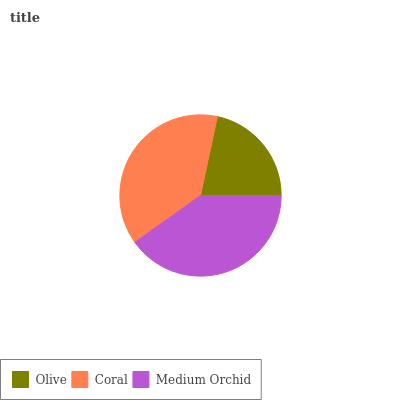Is Olive the minimum?
Answer yes or no. Yes. Is Medium Orchid the maximum?
Answer yes or no. Yes. Is Coral the minimum?
Answer yes or no. No. Is Coral the maximum?
Answer yes or no. No. Is Coral greater than Olive?
Answer yes or no. Yes. Is Olive less than Coral?
Answer yes or no. Yes. Is Olive greater than Coral?
Answer yes or no. No. Is Coral less than Olive?
Answer yes or no. No. Is Coral the high median?
Answer yes or no. Yes. Is Coral the low median?
Answer yes or no. Yes. Is Medium Orchid the high median?
Answer yes or no. No. Is Medium Orchid the low median?
Answer yes or no. No. 